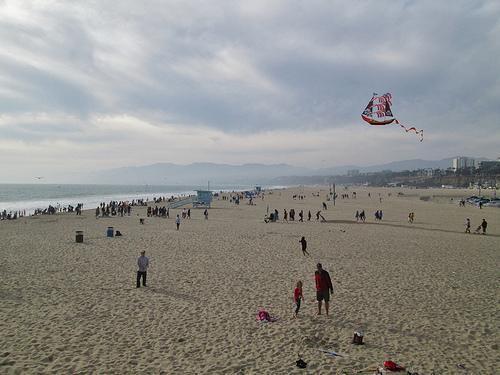How many kites are there?
Give a very brief answer. 1. 